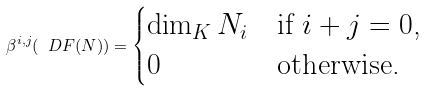Convert formula to latex. <formula><loc_0><loc_0><loc_500><loc_500>\beta ^ { i , j } ( \ D F ( N ) ) = \begin{cases} \dim _ { K } N _ { i } & \text {if $i+j = 0$,} \\ 0 & \text {otherwise.} \end{cases}</formula> 